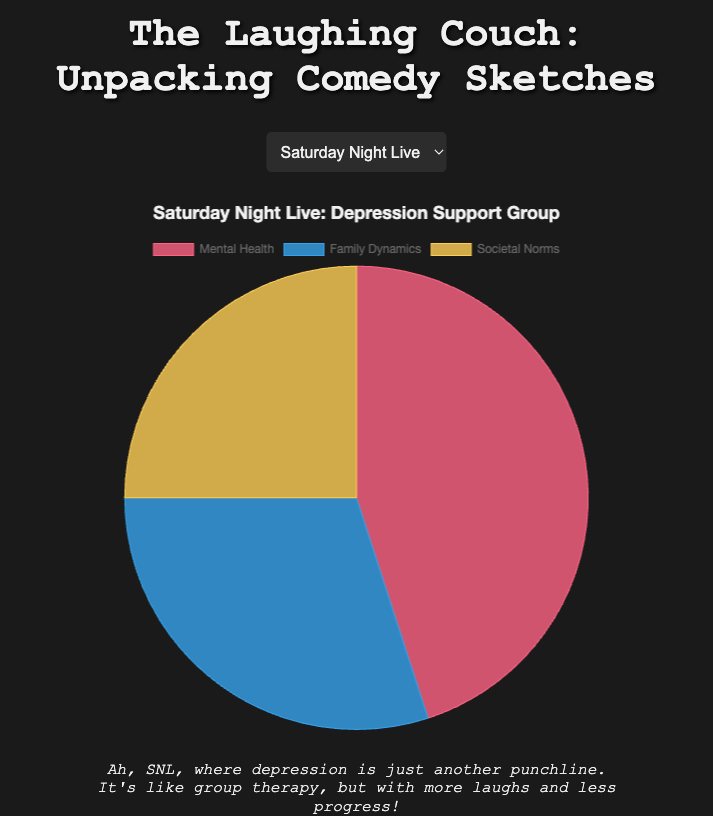What percentage of the 'Depression Support Group' sketch from SNL covers Mental Health and Societal Norms combined? Mental Health covers 45% and Societal Norms covers 25%. Adding these gives 45 + 25 = 70%.
Answer: 70% Which show has the highest focus on Mental Health in their sketches? Mental Health percentages are: SNL (45%), The Simpsons (50%), Friends (55%), Brooklyn Nine-Nine (60%). The highest is 60% from Brooklyn Nine-Nine.
Answer: Brooklyn Nine-Nine In the 'Jake’s PTSD' sketch, how does the percentage of Family Dynamics compare to Societal Norms? Family Dynamics is 25% and Societal Norms is 15%. Comparing, 25% is greater than 15%.
Answer: Family Dynamics is greater What is the average percentage of Family Dynamics across all the shows? Family Dynamics percentages are 30%, 35%, 20%, and 25%. Sum them up: 30 + 35 + 20 + 25 = 110. Divide by 4: 110 ÷ 4 = 27.5%.
Answer: 27.5% Is the focus on Mental Health in the 'Ross’ Anxiety' sketch greater than the combined focus on Societal Norms for all sketches? Mental Health in 'Ross’ Anxiety' is 55%. Societal Norms for all sketches combined is 25% (SNL) + 15% (The Simpsons) + 25% (Friends) + 15% (Brooklyn Nine-Nine) = 80%. 55% is less than 80%.
Answer: No Which sketch has an equal percentage distribution of Mental Health and Family Dynamics? Checking sketches: SNL (45% vs 30%), The Simpsons (50% vs 35%), Friends (55% vs 20%), Brooklyn Nine-Nine (60% vs 25%). None have equal distribution.
Answer: None How much more focused is 'Homer’s Therapy' on Mental Health compared to Societal Norms? Mental Health in 'Homer’s Therapy' is 50% and Societal Norms is 15%. Difference: 50 - 15 = 35%.
Answer: 35% more In the 'Depression Support Group' sketch from SNL, what is the visual color representing Societal Norms? Three colors are assigned: Mental Health (red), Family Dynamics (blue), Societal Norms (yellow). Visual check confirms Societal Norms is yellow.
Answer: Yellow 